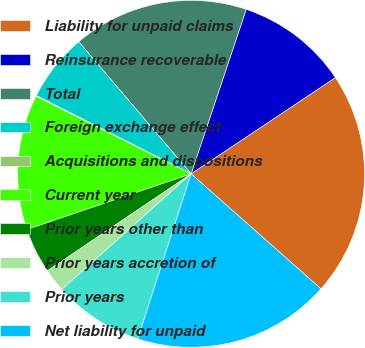Convert chart. <chart><loc_0><loc_0><loc_500><loc_500><pie_chart><fcel>Liability for unpaid claims<fcel>Reinsurance recoverable<fcel>Total<fcel>Foreign exchange effect<fcel>Acquisitions and dispositions<fcel>Current year<fcel>Prior years other than<fcel>Prior years accretion of<fcel>Prior years<fcel>Net liability for unpaid<nl><fcel>20.9%<fcel>10.49%<fcel>16.36%<fcel>6.33%<fcel>0.08%<fcel>12.57%<fcel>4.25%<fcel>2.16%<fcel>8.41%<fcel>18.44%<nl></chart> 